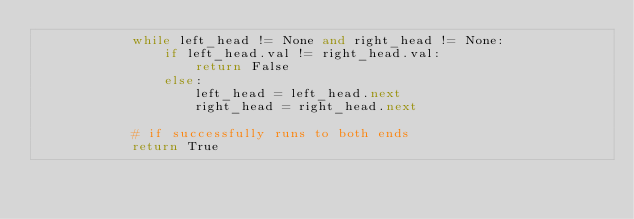Convert code to text. <code><loc_0><loc_0><loc_500><loc_500><_Python_>            while left_head != None and right_head != None:
                if left_head.val != right_head.val:
                    return False
                else:
                    left_head = left_head.next
                    right_head = right_head.next

            # if successfully runs to both ends
            return True
</code> 